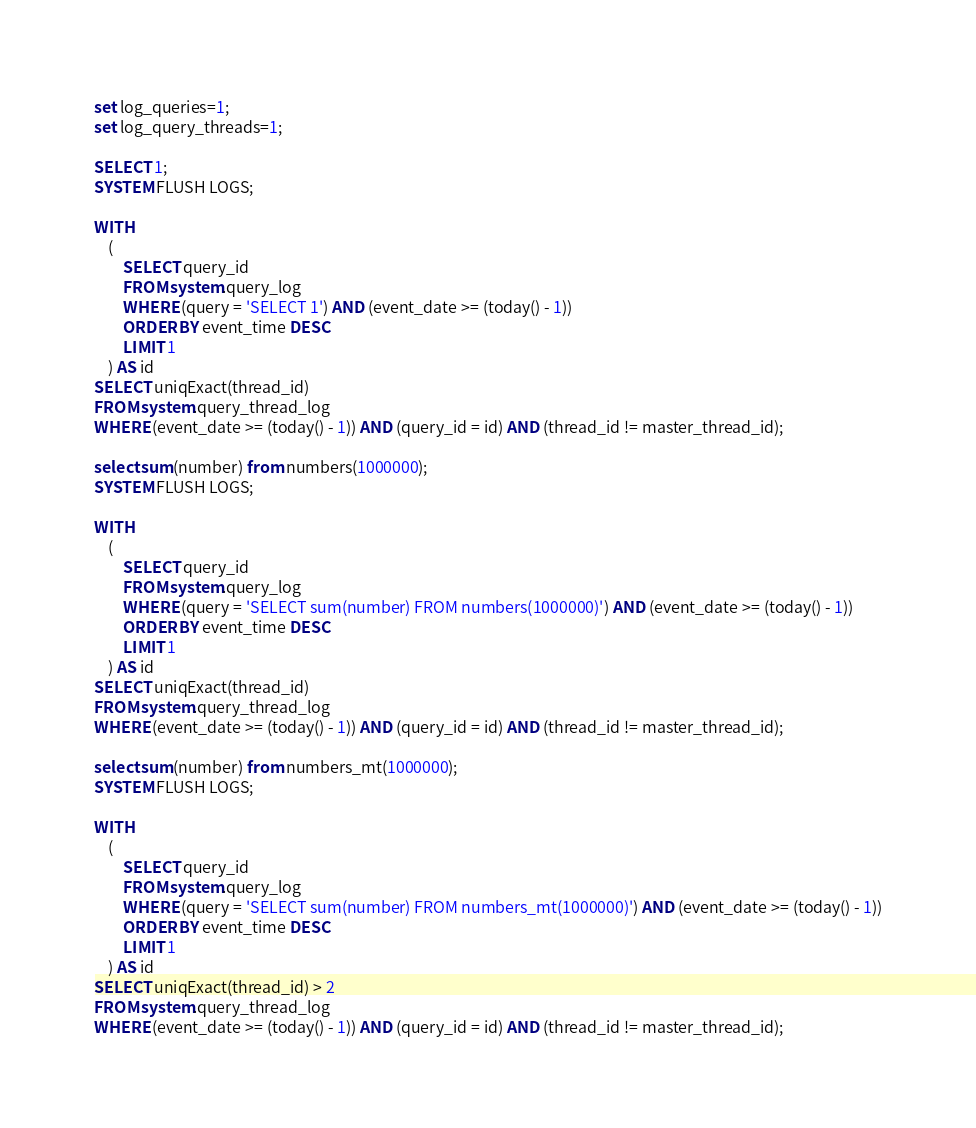<code> <loc_0><loc_0><loc_500><loc_500><_SQL_>set log_queries=1;
set log_query_threads=1;

SELECT 1;
SYSTEM FLUSH LOGS;

WITH 
    (
        SELECT query_id
        FROM system.query_log
        WHERE (query = 'SELECT 1') AND (event_date >= (today() - 1))
        ORDER BY event_time DESC
        LIMIT 1
    ) AS id
SELECT uniqExact(thread_id)
FROM system.query_thread_log
WHERE (event_date >= (today() - 1)) AND (query_id = id) AND (thread_id != master_thread_id);

select sum(number) from numbers(1000000);
SYSTEM FLUSH LOGS;

WITH 
    (
        SELECT query_id
        FROM system.query_log
        WHERE (query = 'SELECT sum(number) FROM numbers(1000000)') AND (event_date >= (today() - 1))
        ORDER BY event_time DESC
        LIMIT 1
    ) AS id
SELECT uniqExact(thread_id)
FROM system.query_thread_log
WHERE (event_date >= (today() - 1)) AND (query_id = id) AND (thread_id != master_thread_id);

select sum(number) from numbers_mt(1000000);
SYSTEM FLUSH LOGS;

WITH 
    (
        SELECT query_id
        FROM system.query_log
        WHERE (query = 'SELECT sum(number) FROM numbers_mt(1000000)') AND (event_date >= (today() - 1))
        ORDER BY event_time DESC
        LIMIT 1
    ) AS id
SELECT uniqExact(thread_id) > 2
FROM system.query_thread_log
WHERE (event_date >= (today() - 1)) AND (query_id = id) AND (thread_id != master_thread_id);
</code> 